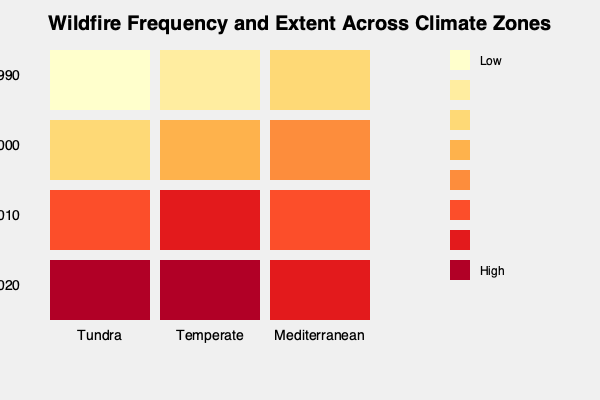Based on the heat map provided, which climate zone shows the most significant increase in wildfire frequency and extent from the 1980s to the 2020s, and what could be a potential explanation for this trend? To answer this question, we need to analyze the heat map for each climate zone:

1. Tundra:
   - 1980-1990: Very low (light yellow)
   - 2010-2020: Very high (dark red)
   Significant increase observed.

2. Temperate:
   - 1980-1990: Low (light orange)
   - 2010-2020: Very high (dark red)
   Significant increase observed.

3. Mediterranean:
   - 1980-1990: Moderate (orange)
   - 2010-2020: High (red)
   Increase observed, but less dramatic than Tundra and Temperate.

The Tundra zone shows the most significant increase, going from very low to very high over the 40-year period.

Potential explanation:
1. Rising temperatures: Tundra regions are experiencing more rapid warming due to climate change, leading to:
   a. Longer fire seasons
   b. Drier conditions
   c. Increased vegetation growth (fuel for fires)

2. Permafrost thaw: Releasing stored carbon and methane, further contributing to warming and creating drier conditions.

3. Changes in precipitation patterns: Potentially leading to more frequent droughts in Tundra regions.

4. Increased lightning activity: More thunderstorms due to warmer air, providing more ignition sources.

5. Human activity: Increased access to previously remote areas, potentially leading to more human-caused fires.

The combination of these factors, particularly the rapid warming and ecosystem changes in Tundra regions, likely contributes to the dramatic increase in wildfire frequency and extent observed in the heat map.
Answer: Tundra; rapid warming, permafrost thaw, and ecosystem changes. 